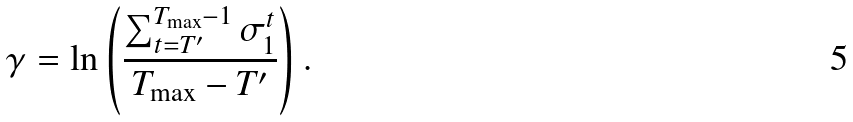<formula> <loc_0><loc_0><loc_500><loc_500>\gamma = \ln \left ( \frac { \sum _ { t = T ^ { \prime } } ^ { T _ { \max } - 1 } \sigma _ { 1 } ^ { t } } { T _ { \max } - T ^ { \prime } } \right ) .</formula> 